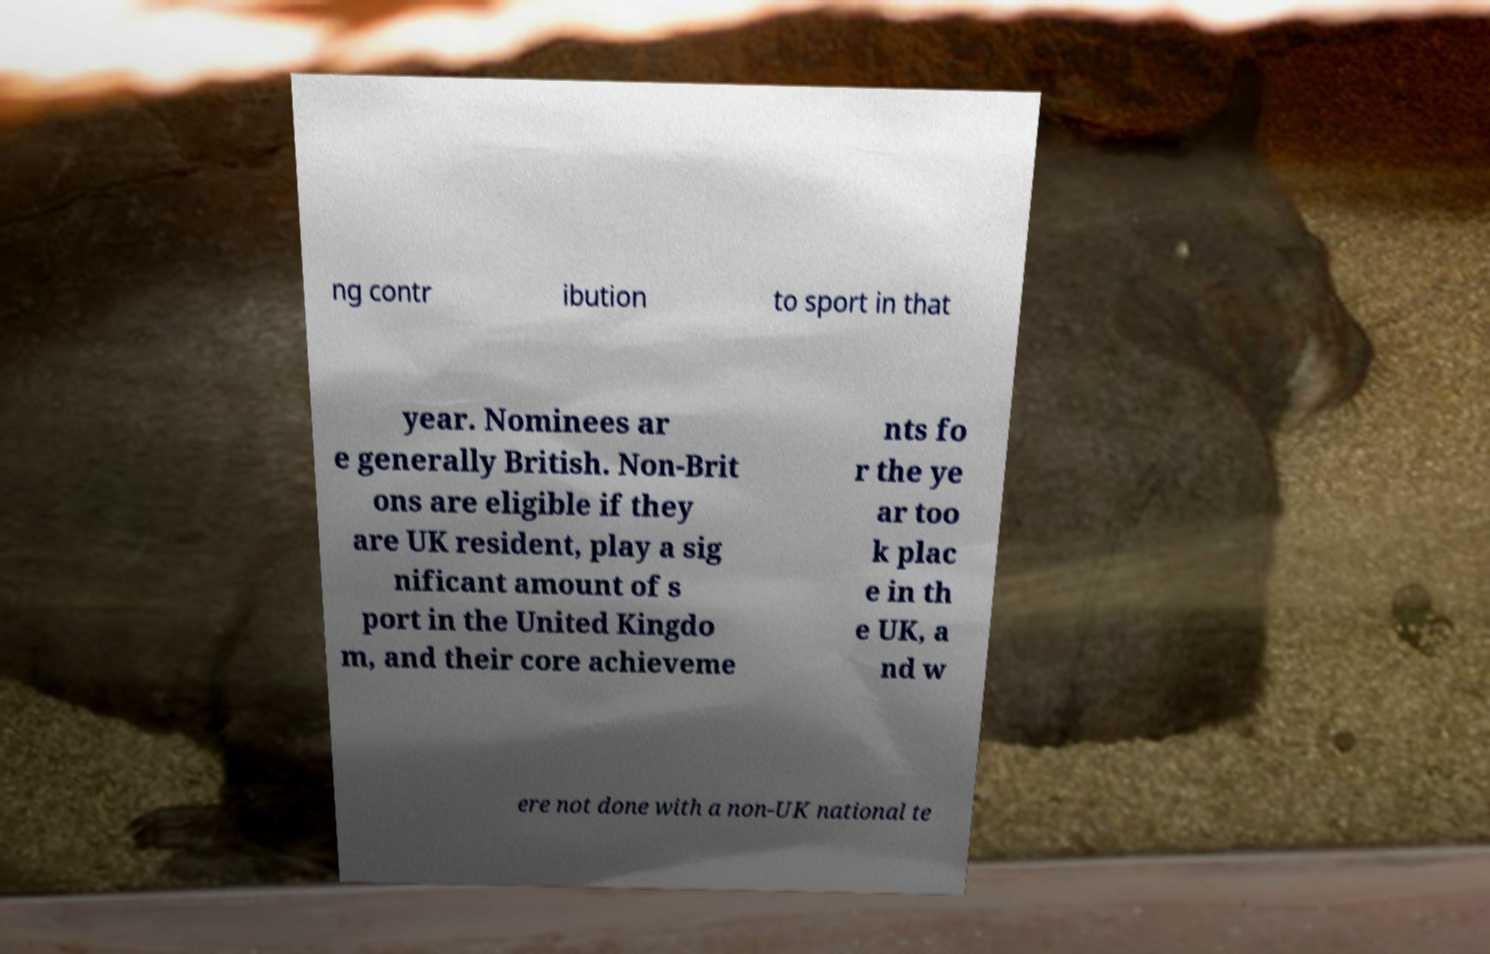For documentation purposes, I need the text within this image transcribed. Could you provide that? ng contr ibution to sport in that year. Nominees ar e generally British. Non-Brit ons are eligible if they are UK resident, play a sig nificant amount of s port in the United Kingdo m, and their core achieveme nts fo r the ye ar too k plac e in th e UK, a nd w ere not done with a non-UK national te 